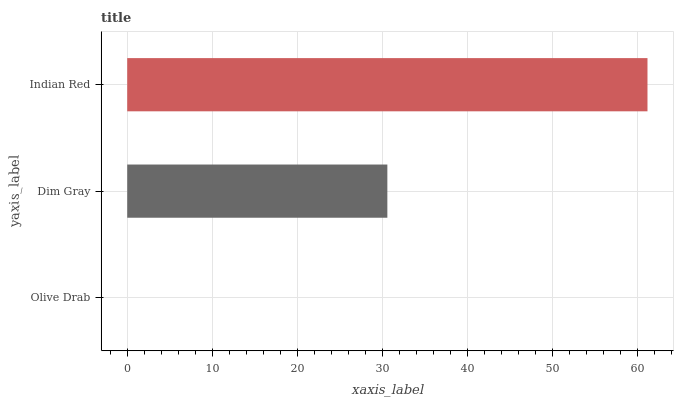Is Olive Drab the minimum?
Answer yes or no. Yes. Is Indian Red the maximum?
Answer yes or no. Yes. Is Dim Gray the minimum?
Answer yes or no. No. Is Dim Gray the maximum?
Answer yes or no. No. Is Dim Gray greater than Olive Drab?
Answer yes or no. Yes. Is Olive Drab less than Dim Gray?
Answer yes or no. Yes. Is Olive Drab greater than Dim Gray?
Answer yes or no. No. Is Dim Gray less than Olive Drab?
Answer yes or no. No. Is Dim Gray the high median?
Answer yes or no. Yes. Is Dim Gray the low median?
Answer yes or no. Yes. Is Indian Red the high median?
Answer yes or no. No. Is Olive Drab the low median?
Answer yes or no. No. 